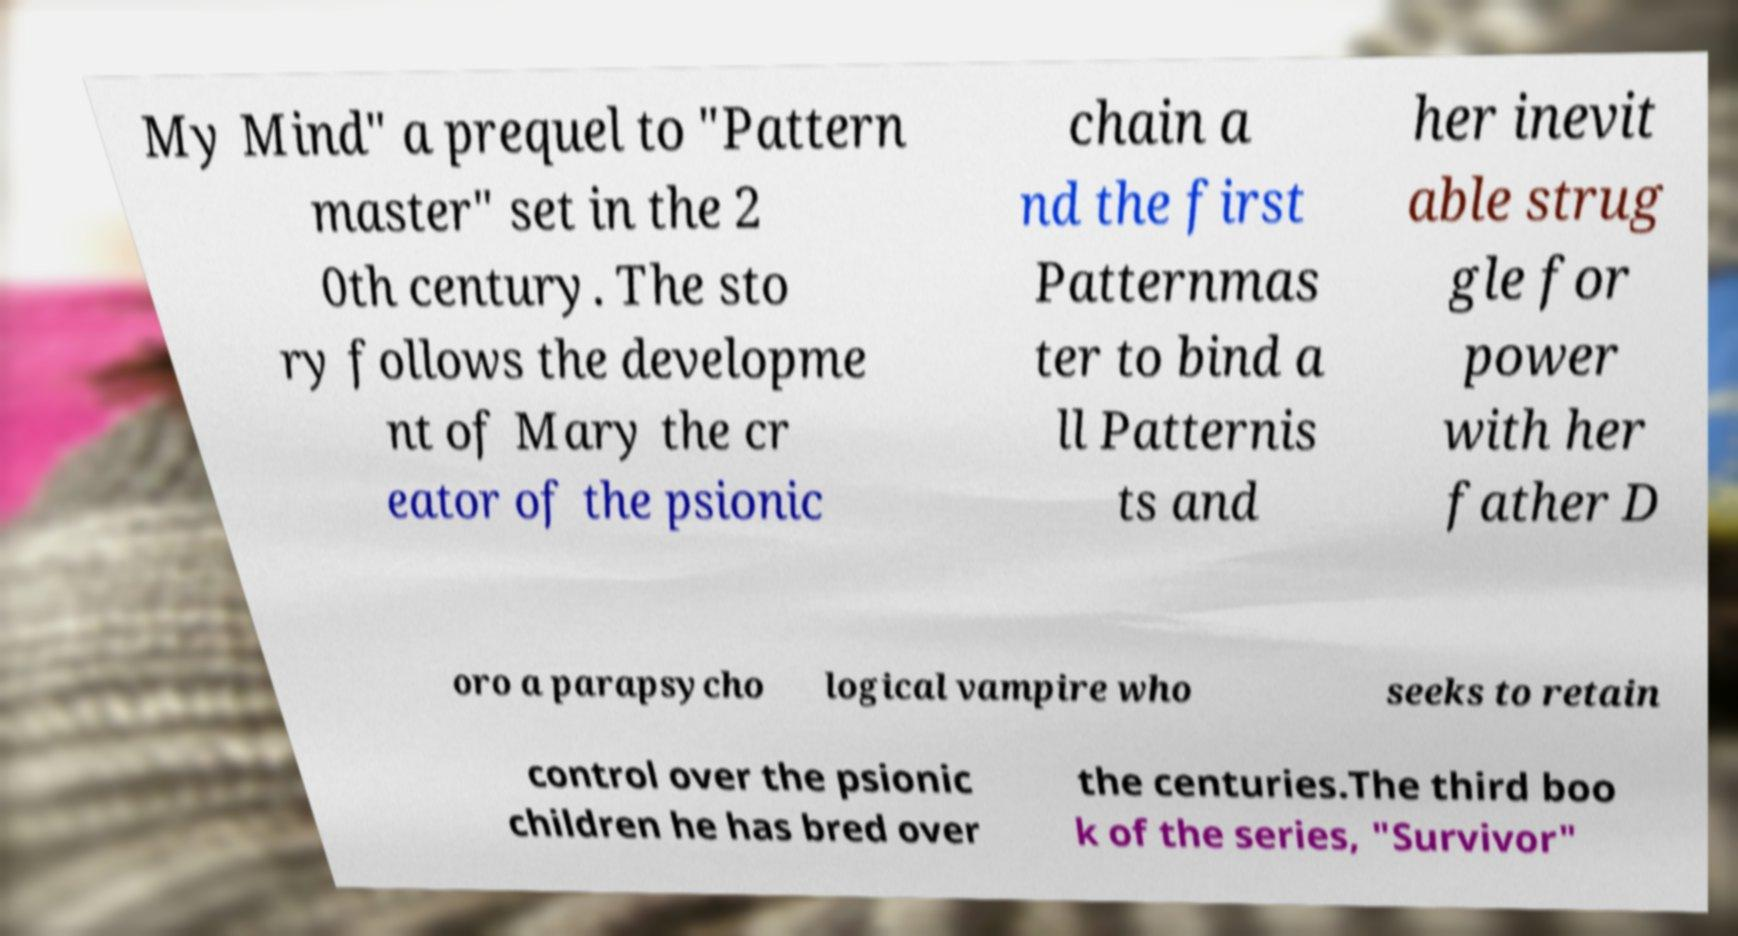There's text embedded in this image that I need extracted. Can you transcribe it verbatim? My Mind" a prequel to "Pattern master" set in the 2 0th century. The sto ry follows the developme nt of Mary the cr eator of the psionic chain a nd the first Patternmas ter to bind a ll Patternis ts and her inevit able strug gle for power with her father D oro a parapsycho logical vampire who seeks to retain control over the psionic children he has bred over the centuries.The third boo k of the series, "Survivor" 